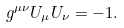Convert formula to latex. <formula><loc_0><loc_0><loc_500><loc_500>g ^ { \mu \nu } U _ { \mu } U _ { \nu } = - 1 .</formula> 